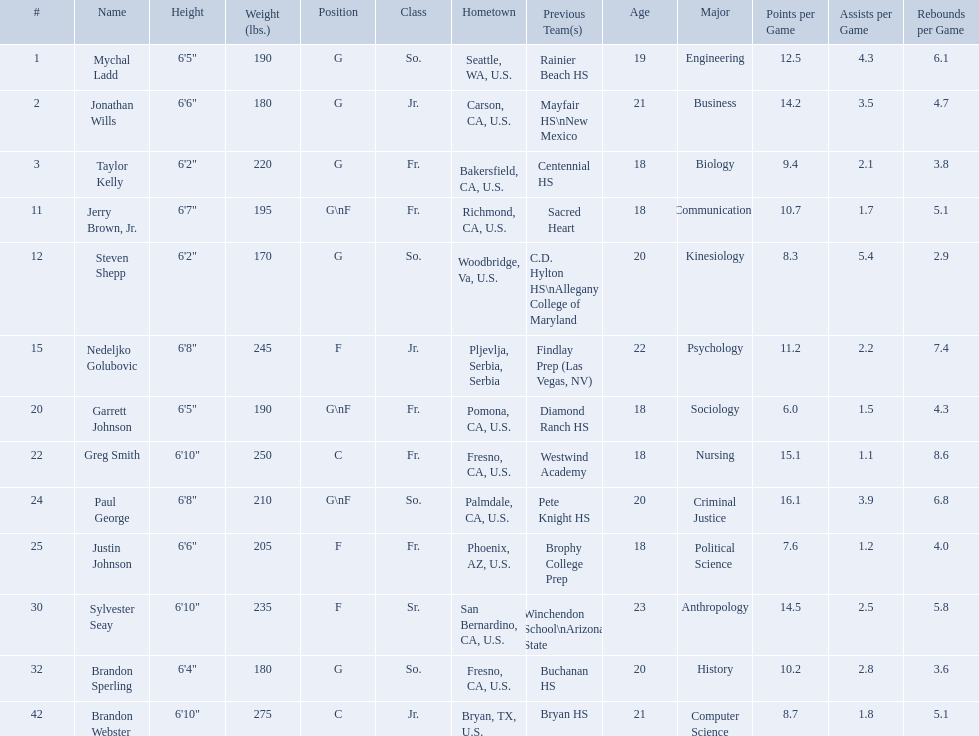What are the listed classes of the players? So., Jr., Fr., Fr., So., Jr., Fr., Fr., So., Fr., Sr., So., Jr. Which of these is not from the us? Jr. To which name does that entry correspond to? Nedeljko Golubovic. Who are all the players in the 2009-10 fresno state bulldogs men's basketball team? Mychal Ladd, Jonathan Wills, Taylor Kelly, Jerry Brown, Jr., Steven Shepp, Nedeljko Golubovic, Garrett Johnson, Greg Smith, Paul George, Justin Johnson, Sylvester Seay, Brandon Sperling, Brandon Webster. Of these players, who are the ones who play forward? Jerry Brown, Jr., Nedeljko Golubovic, Garrett Johnson, Paul George, Justin Johnson, Sylvester Seay. Of these players, which ones only play forward and no other position? Nedeljko Golubovic, Justin Johnson, Sylvester Seay. Of these players, who is the shortest? Justin Johnson. What are the names for all players? Mychal Ladd, Jonathan Wills, Taylor Kelly, Jerry Brown, Jr., Steven Shepp, Nedeljko Golubovic, Garrett Johnson, Greg Smith, Paul George, Justin Johnson, Sylvester Seay, Brandon Sperling, Brandon Webster. Which players are taller than 6'8? Nedeljko Golubovic, Greg Smith, Paul George, Sylvester Seay, Brandon Webster. How tall is paul george? 6'8". How tall is greg smith? 6'10". Of these two, which it tallest? Greg Smith. Who are the players for the 2009-10 fresno state bulldogs men's basketball team? Mychal Ladd, Jonathan Wills, Taylor Kelly, Jerry Brown, Jr., Steven Shepp, Nedeljko Golubovic, Garrett Johnson, Greg Smith, Paul George, Justin Johnson, Sylvester Seay, Brandon Sperling, Brandon Webster. What are their heights? 6'5", 6'6", 6'2", 6'7", 6'2", 6'8", 6'5", 6'10", 6'8", 6'6", 6'10", 6'4", 6'10". What is the shortest height? 6'2", 6'2". Can you give me this table in json format? {'header': ['#', 'Name', 'Height', 'Weight (lbs.)', 'Position', 'Class', 'Hometown', 'Previous Team(s)', 'Age', 'Major', 'Points per Game', 'Assists per Game', 'Rebounds per Game'], 'rows': [['1', 'Mychal Ladd', '6\'5"', '190', 'G', 'So.', 'Seattle, WA, U.S.', 'Rainier Beach HS', '19', 'Engineering', '12.5', '4.3', '6.1'], ['2', 'Jonathan Wills', '6\'6"', '180', 'G', 'Jr.', 'Carson, CA, U.S.', 'Mayfair HS\\nNew Mexico', '21', 'Business', '14.2', '3.5', '4.7'], ['3', 'Taylor Kelly', '6\'2"', '220', 'G', 'Fr.', 'Bakersfield, CA, U.S.', 'Centennial HS', '18', 'Biology', '9.4', '2.1', '3.8'], ['11', 'Jerry Brown, Jr.', '6\'7"', '195', 'G\\nF', 'Fr.', 'Richmond, CA, U.S.', 'Sacred Heart', '18', 'Communications', '10.7', '1.7', '5.1'], ['12', 'Steven Shepp', '6\'2"', '170', 'G', 'So.', 'Woodbridge, Va, U.S.', 'C.D. Hylton HS\\nAllegany College of Maryland', '20', 'Kinesiology', '8.3', '5.4', '2.9'], ['15', 'Nedeljko Golubovic', '6\'8"', '245', 'F', 'Jr.', 'Pljevlja, Serbia, Serbia', 'Findlay Prep (Las Vegas, NV)', '22', 'Psychology', '11.2', '2.2', '7.4'], ['20', 'Garrett Johnson', '6\'5"', '190', 'G\\nF', 'Fr.', 'Pomona, CA, U.S.', 'Diamond Ranch HS', '18', 'Sociology', '6.0', '1.5', '4.3'], ['22', 'Greg Smith', '6\'10"', '250', 'C', 'Fr.', 'Fresno, CA, U.S.', 'Westwind Academy', '18', 'Nursing', '15.1', '1.1', '8.6'], ['24', 'Paul George', '6\'8"', '210', 'G\\nF', 'So.', 'Palmdale, CA, U.S.', 'Pete Knight HS', '20', 'Criminal Justice', '16.1', '3.9', '6.8'], ['25', 'Justin Johnson', '6\'6"', '205', 'F', 'Fr.', 'Phoenix, AZ, U.S.', 'Brophy College Prep', '18', 'Political Science', '7.6', '1.2', '4.0'], ['30', 'Sylvester Seay', '6\'10"', '235', 'F', 'Sr.', 'San Bernardino, CA, U.S.', 'Winchendon School\\nArizona State', '23', 'Anthropology', '14.5', '2.5', '5.8'], ['32', 'Brandon Sperling', '6\'4"', '180', 'G', 'So.', 'Fresno, CA, U.S.', 'Buchanan HS', '20', 'History', '10.2', '2.8', '3.6'], ['42', 'Brandon Webster', '6\'10"', '275', 'C', 'Jr.', 'Bryan, TX, U.S.', 'Bryan HS', '21', 'Computer Science', '8.7', '1.8', '5.1']]} What is the lowest weight? 6'2". Which player is it? Steven Shepp. 